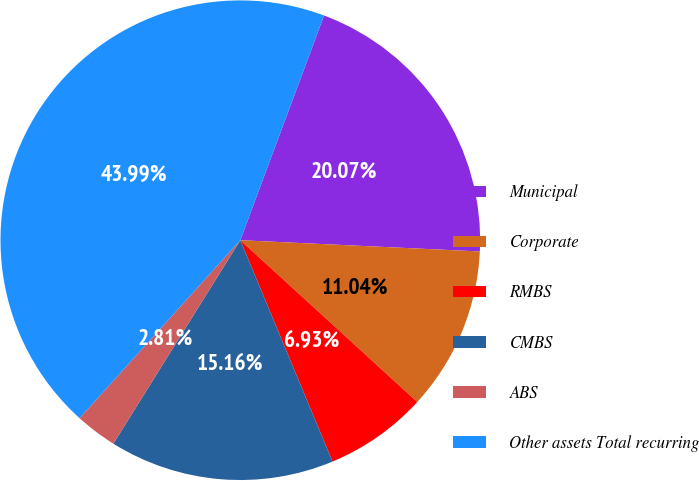Convert chart to OTSL. <chart><loc_0><loc_0><loc_500><loc_500><pie_chart><fcel>Municipal<fcel>Corporate<fcel>RMBS<fcel>CMBS<fcel>ABS<fcel>Other assets Total recurring<nl><fcel>20.07%<fcel>11.04%<fcel>6.93%<fcel>15.16%<fcel>2.81%<fcel>43.99%<nl></chart> 